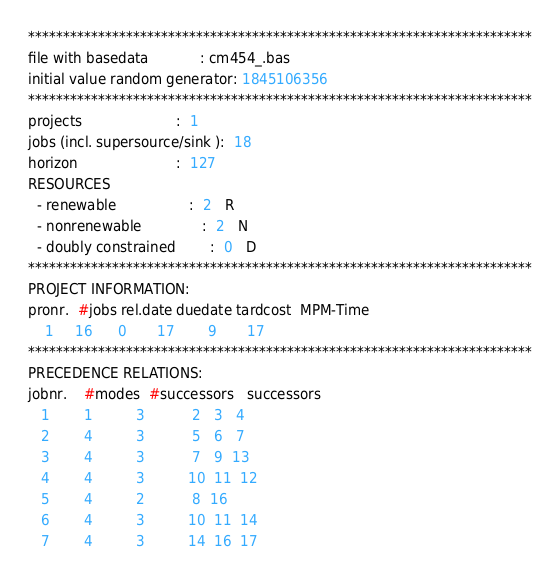Convert code to text. <code><loc_0><loc_0><loc_500><loc_500><_ObjectiveC_>************************************************************************
file with basedata            : cm454_.bas
initial value random generator: 1845106356
************************************************************************
projects                      :  1
jobs (incl. supersource/sink ):  18
horizon                       :  127
RESOURCES
  - renewable                 :  2   R
  - nonrenewable              :  2   N
  - doubly constrained        :  0   D
************************************************************************
PROJECT INFORMATION:
pronr.  #jobs rel.date duedate tardcost  MPM-Time
    1     16      0       17        9       17
************************************************************************
PRECEDENCE RELATIONS:
jobnr.    #modes  #successors   successors
   1        1          3           2   3   4
   2        4          3           5   6   7
   3        4          3           7   9  13
   4        4          3          10  11  12
   5        4          2           8  16
   6        4          3          10  11  14
   7        4          3          14  16  17</code> 